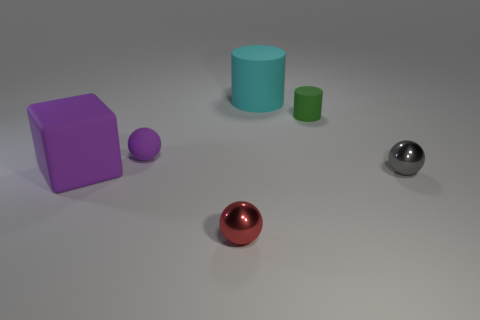Is the color of the big matte cube the same as the rubber sphere?
Give a very brief answer. Yes. There is a small thing that is the same color as the block; what material is it?
Make the answer very short. Rubber. Is there a purple rubber object that has the same size as the cyan thing?
Provide a succinct answer. Yes. What is the shape of the gray object that is the same size as the green cylinder?
Give a very brief answer. Sphere. How many other things are the same color as the matte block?
Ensure brevity in your answer.  1. There is a matte object that is right of the rubber cube and in front of the green matte cylinder; what shape is it?
Your answer should be compact. Sphere. Are there any shiny things to the left of the cylinder that is behind the tiny object that is behind the purple rubber ball?
Ensure brevity in your answer.  Yes. How many other objects are there of the same material as the red sphere?
Your answer should be compact. 1. How many blue spheres are there?
Give a very brief answer. 0. What number of objects are big matte things or large things that are behind the green rubber cylinder?
Provide a short and direct response. 2. 